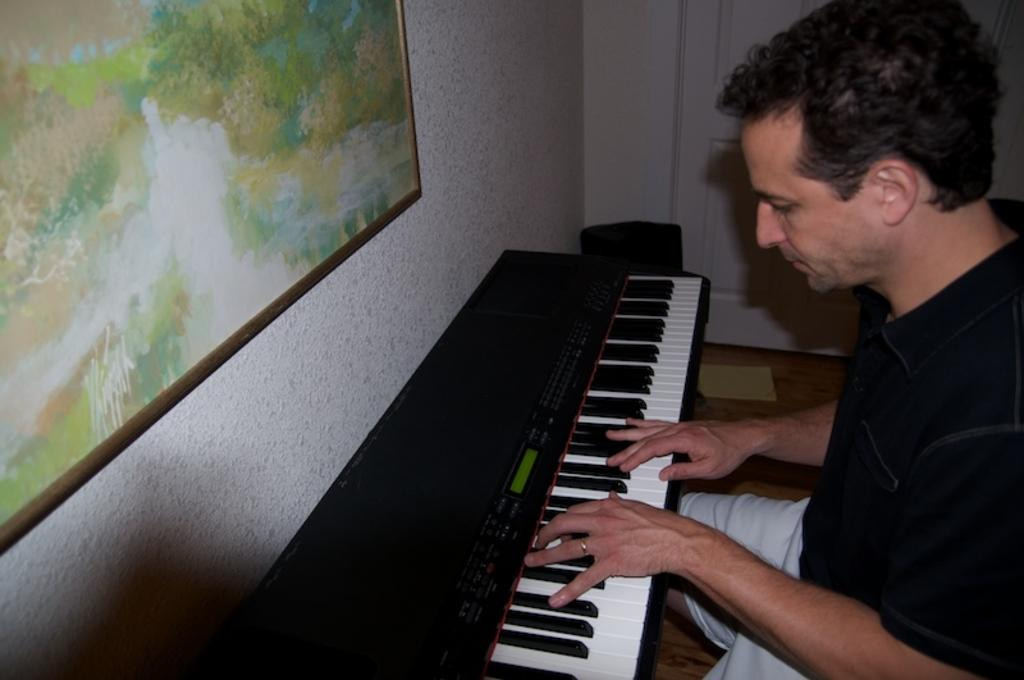What is the man in the image doing? The man is playing a piano in the image. Can you describe anything else in the room where the man is playing the piano? There is a poster on the wall in the image. Where is the donkey located in the image? There is no donkey present in the image. What type of rings can be seen on the man's fingers while he is playing the piano? There is no information about rings on the man's fingers in the image. 